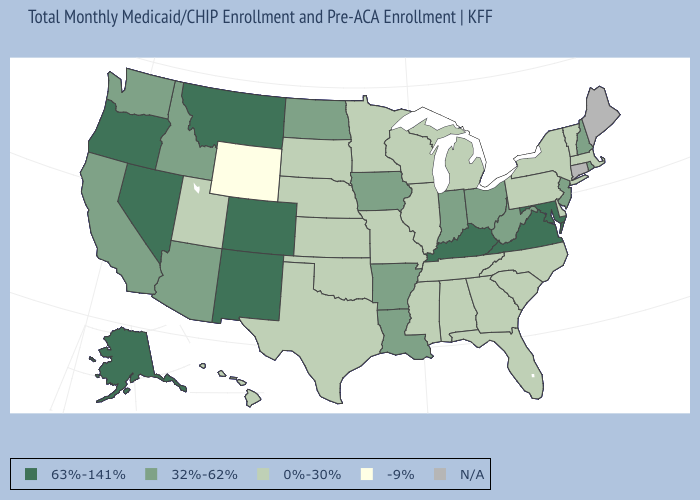Does the map have missing data?
Give a very brief answer. Yes. How many symbols are there in the legend?
Answer briefly. 5. What is the value of Tennessee?
Quick response, please. 0%-30%. Name the states that have a value in the range 63%-141%?
Be succinct. Alaska, Colorado, Kentucky, Maryland, Montana, Nevada, New Mexico, Oregon, Virginia. What is the value of Iowa?
Concise answer only. 32%-62%. What is the value of Minnesota?
Short answer required. 0%-30%. Name the states that have a value in the range 0%-30%?
Short answer required. Alabama, Delaware, Florida, Georgia, Hawaii, Illinois, Kansas, Massachusetts, Michigan, Minnesota, Mississippi, Missouri, Nebraska, New York, North Carolina, Oklahoma, Pennsylvania, South Carolina, South Dakota, Tennessee, Texas, Utah, Vermont, Wisconsin. What is the highest value in the USA?
Quick response, please. 63%-141%. Which states have the lowest value in the Northeast?
Answer briefly. Massachusetts, New York, Pennsylvania, Vermont. Is the legend a continuous bar?
Give a very brief answer. No. Among the states that border Utah , does Idaho have the lowest value?
Short answer required. No. Which states have the lowest value in the USA?
Give a very brief answer. Wyoming. Which states hav the highest value in the Northeast?
Short answer required. New Hampshire, New Jersey, Rhode Island. 